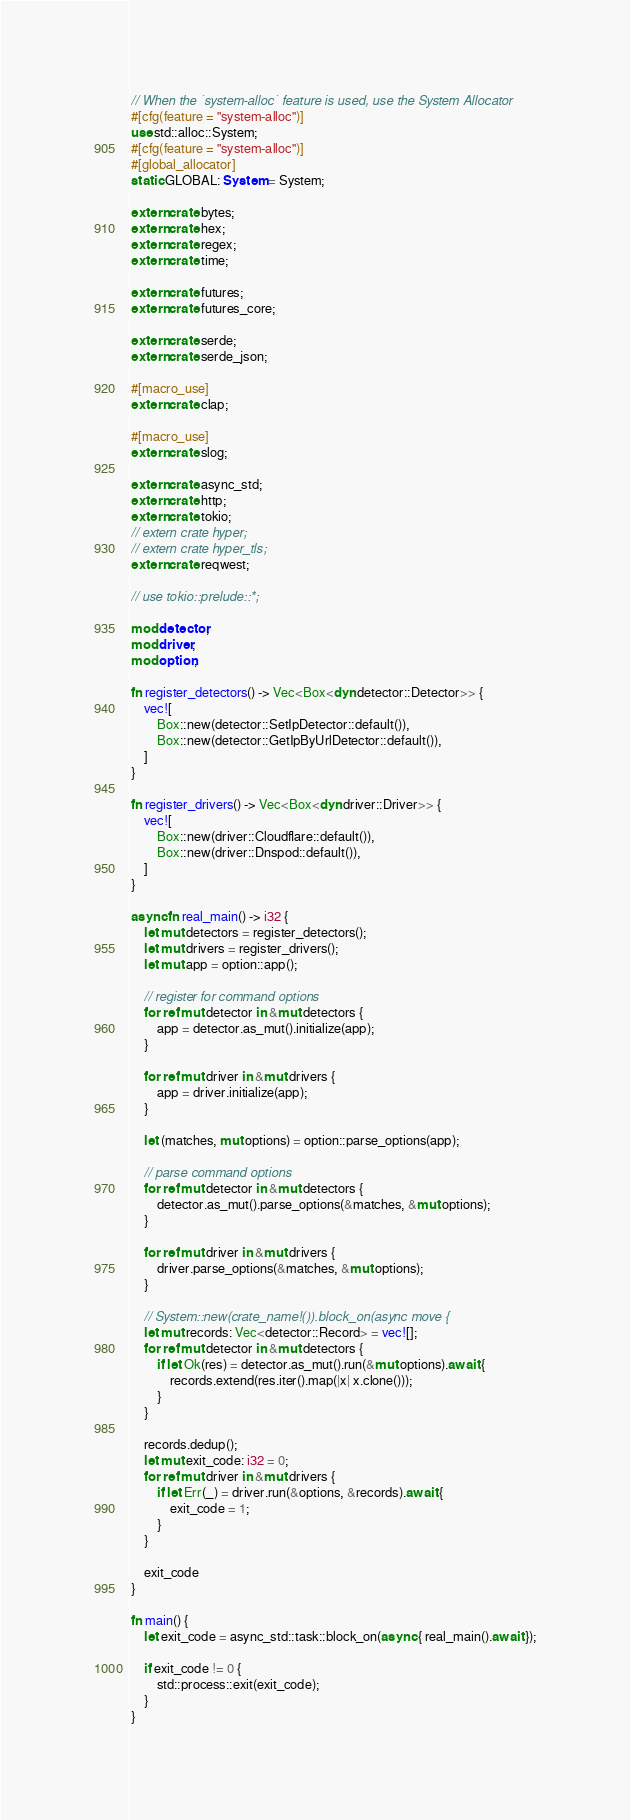<code> <loc_0><loc_0><loc_500><loc_500><_Rust_>// When the `system-alloc` feature is used, use the System Allocator
#[cfg(feature = "system-alloc")]
use std::alloc::System;
#[cfg(feature = "system-alloc")]
#[global_allocator]
static GLOBAL: System = System;

extern crate bytes;
extern crate hex;
extern crate regex;
extern crate time;

extern crate futures;
extern crate futures_core;

extern crate serde;
extern crate serde_json;

#[macro_use]
extern crate clap;

#[macro_use]
extern crate slog;

extern crate async_std;
extern crate http;
extern crate tokio;
// extern crate hyper;
// extern crate hyper_tls;
extern crate reqwest;

// use tokio::prelude::*;

mod detector;
mod driver;
mod option;

fn register_detectors() -> Vec<Box<dyn detector::Detector>> {
    vec![
        Box::new(detector::SetIpDetector::default()),
        Box::new(detector::GetIpByUrlDetector::default()),
    ]
}

fn register_drivers() -> Vec<Box<dyn driver::Driver>> {
    vec![
        Box::new(driver::Cloudflare::default()),
        Box::new(driver::Dnspod::default()),
    ]
}

async fn real_main() -> i32 {
    let mut detectors = register_detectors();
    let mut drivers = register_drivers();
    let mut app = option::app();

    // register for command options
    for ref mut detector in &mut detectors {
        app = detector.as_mut().initialize(app);
    }

    for ref mut driver in &mut drivers {
        app = driver.initialize(app);
    }

    let (matches, mut options) = option::parse_options(app);

    // parse command options
    for ref mut detector in &mut detectors {
        detector.as_mut().parse_options(&matches, &mut options);
    }

    for ref mut driver in &mut drivers {
        driver.parse_options(&matches, &mut options);
    }

    // System::new(crate_name!()).block_on(async move {
    let mut records: Vec<detector::Record> = vec![];
    for ref mut detector in &mut detectors {
        if let Ok(res) = detector.as_mut().run(&mut options).await {
            records.extend(res.iter().map(|x| x.clone()));
        }
    }

    records.dedup();
    let mut exit_code: i32 = 0;
    for ref mut driver in &mut drivers {
        if let Err(_) = driver.run(&options, &records).await {
            exit_code = 1;
        }
    }

    exit_code
}

fn main() {
    let exit_code = async_std::task::block_on(async { real_main().await });

    if exit_code != 0 {
        std::process::exit(exit_code);
    }
}
</code> 